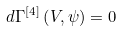<formula> <loc_0><loc_0><loc_500><loc_500>d \Gamma ^ { [ 4 ] } \left ( V , \psi \right ) = 0</formula> 